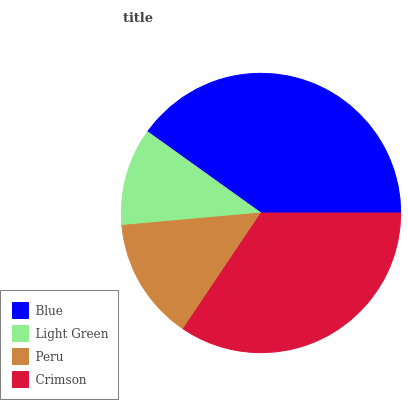Is Light Green the minimum?
Answer yes or no. Yes. Is Blue the maximum?
Answer yes or no. Yes. Is Peru the minimum?
Answer yes or no. No. Is Peru the maximum?
Answer yes or no. No. Is Peru greater than Light Green?
Answer yes or no. Yes. Is Light Green less than Peru?
Answer yes or no. Yes. Is Light Green greater than Peru?
Answer yes or no. No. Is Peru less than Light Green?
Answer yes or no. No. Is Crimson the high median?
Answer yes or no. Yes. Is Peru the low median?
Answer yes or no. Yes. Is Blue the high median?
Answer yes or no. No. Is Light Green the low median?
Answer yes or no. No. 